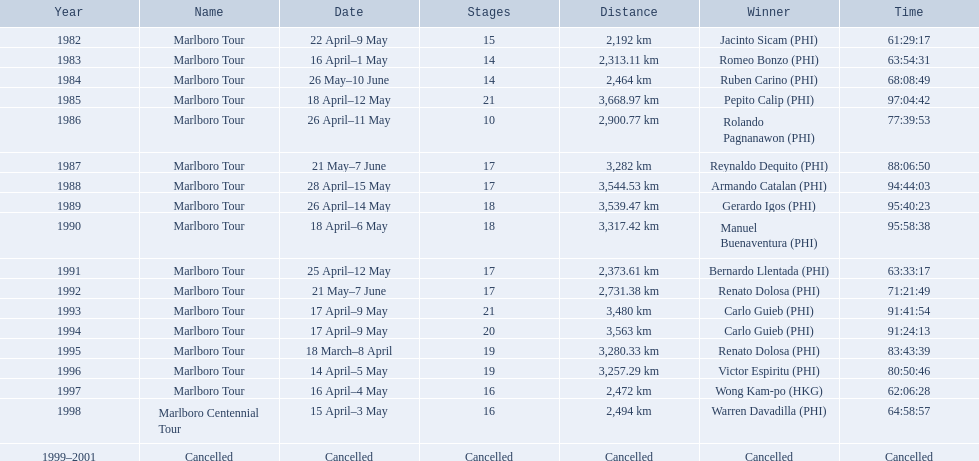What were the event titles during le tour de filipinas? Marlboro Tour, Marlboro Tour, Marlboro Tour, Marlboro Tour, Marlboro Tour, Marlboro Tour, Marlboro Tour, Marlboro Tour, Marlboro Tour, Marlboro Tour, Marlboro Tour, Marlboro Tour, Marlboro Tour, Marlboro Tour, Marlboro Tour, Marlboro Tour, Marlboro Centennial Tour, Cancelled. What were the documented lengths for each marlboro tour? 2,192 km, 2,313.11 km, 2,464 km, 3,668.97 km, 2,900.77 km, 3,282 km, 3,544.53 km, 3,539.47 km, 3,317.42 km, 2,373.61 km, 2,731.38 km, 3,480 km, 3,563 km, 3,280.33 km, 3,257.29 km, 2,472 km. And among those lengths, which one was the greatest? 3,668.97 km. 